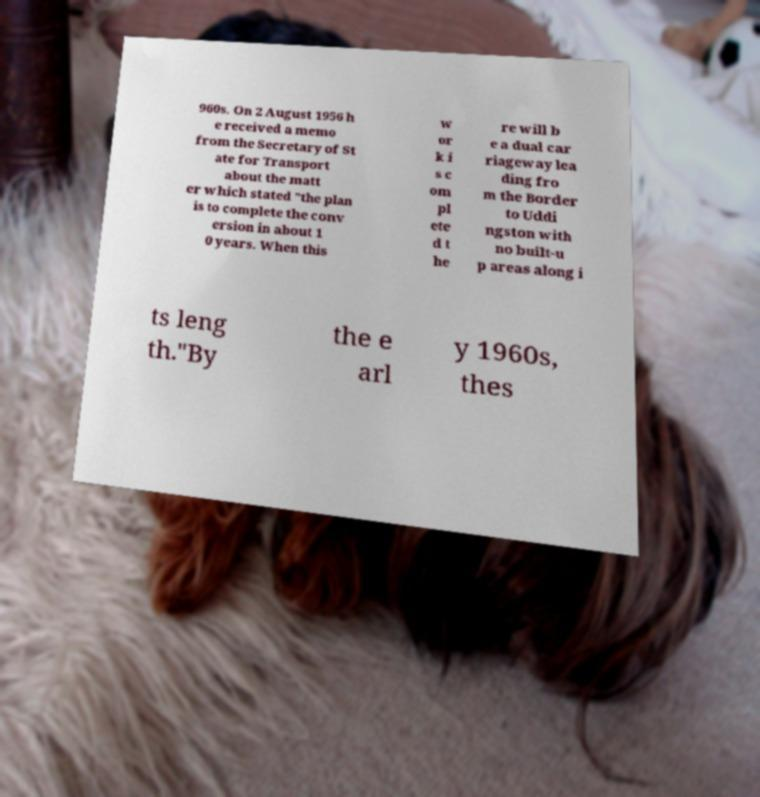Can you read and provide the text displayed in the image?This photo seems to have some interesting text. Can you extract and type it out for me? 960s. On 2 August 1956 h e received a memo from the Secretary of St ate for Transport about the matt er which stated "the plan is to complete the conv ersion in about 1 0 years. When this w or k i s c om pl ete d t he re will b e a dual car riageway lea ding fro m the Border to Uddi ngston with no built-u p areas along i ts leng th."By the e arl y 1960s, thes 